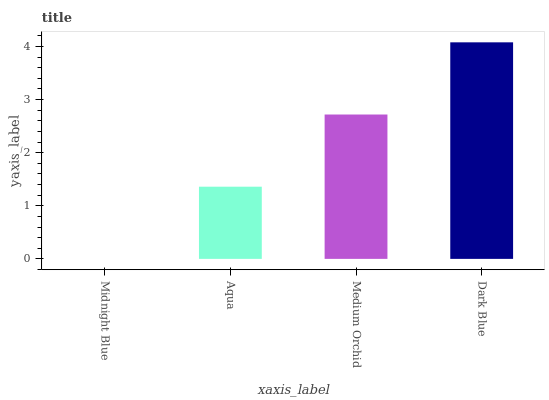Is Midnight Blue the minimum?
Answer yes or no. Yes. Is Dark Blue the maximum?
Answer yes or no. Yes. Is Aqua the minimum?
Answer yes or no. No. Is Aqua the maximum?
Answer yes or no. No. Is Aqua greater than Midnight Blue?
Answer yes or no. Yes. Is Midnight Blue less than Aqua?
Answer yes or no. Yes. Is Midnight Blue greater than Aqua?
Answer yes or no. No. Is Aqua less than Midnight Blue?
Answer yes or no. No. Is Medium Orchid the high median?
Answer yes or no. Yes. Is Aqua the low median?
Answer yes or no. Yes. Is Aqua the high median?
Answer yes or no. No. Is Dark Blue the low median?
Answer yes or no. No. 